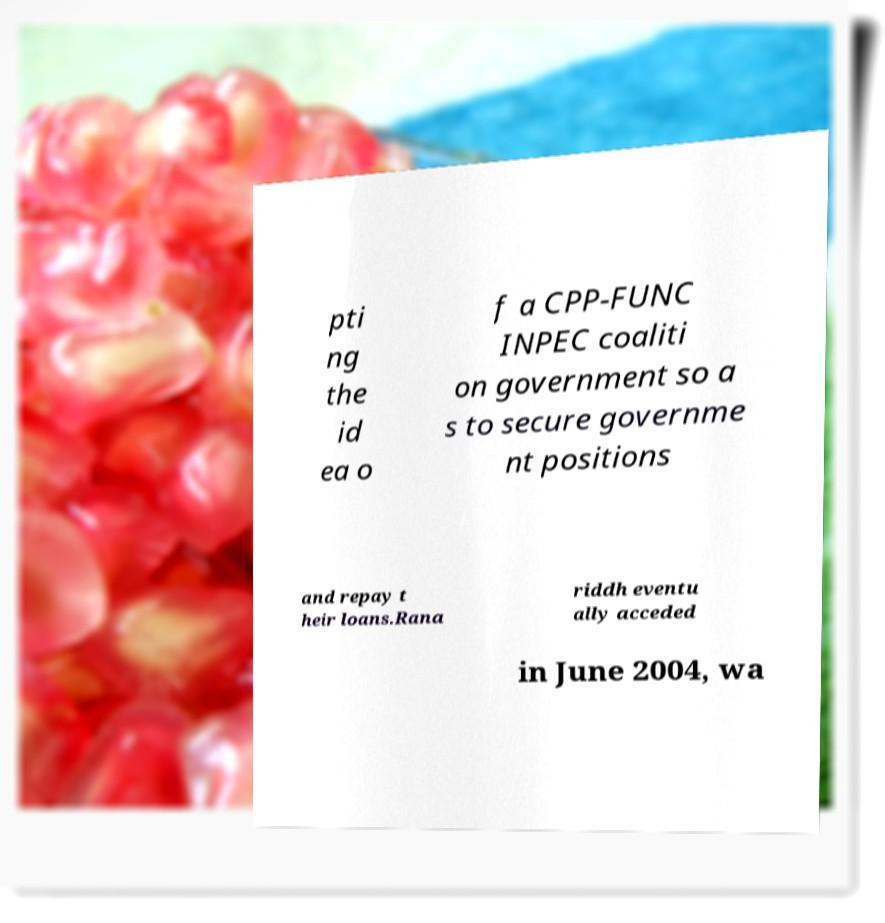Could you extract and type out the text from this image? pti ng the id ea o f a CPP-FUNC INPEC coaliti on government so a s to secure governme nt positions and repay t heir loans.Rana riddh eventu ally acceded in June 2004, wa 